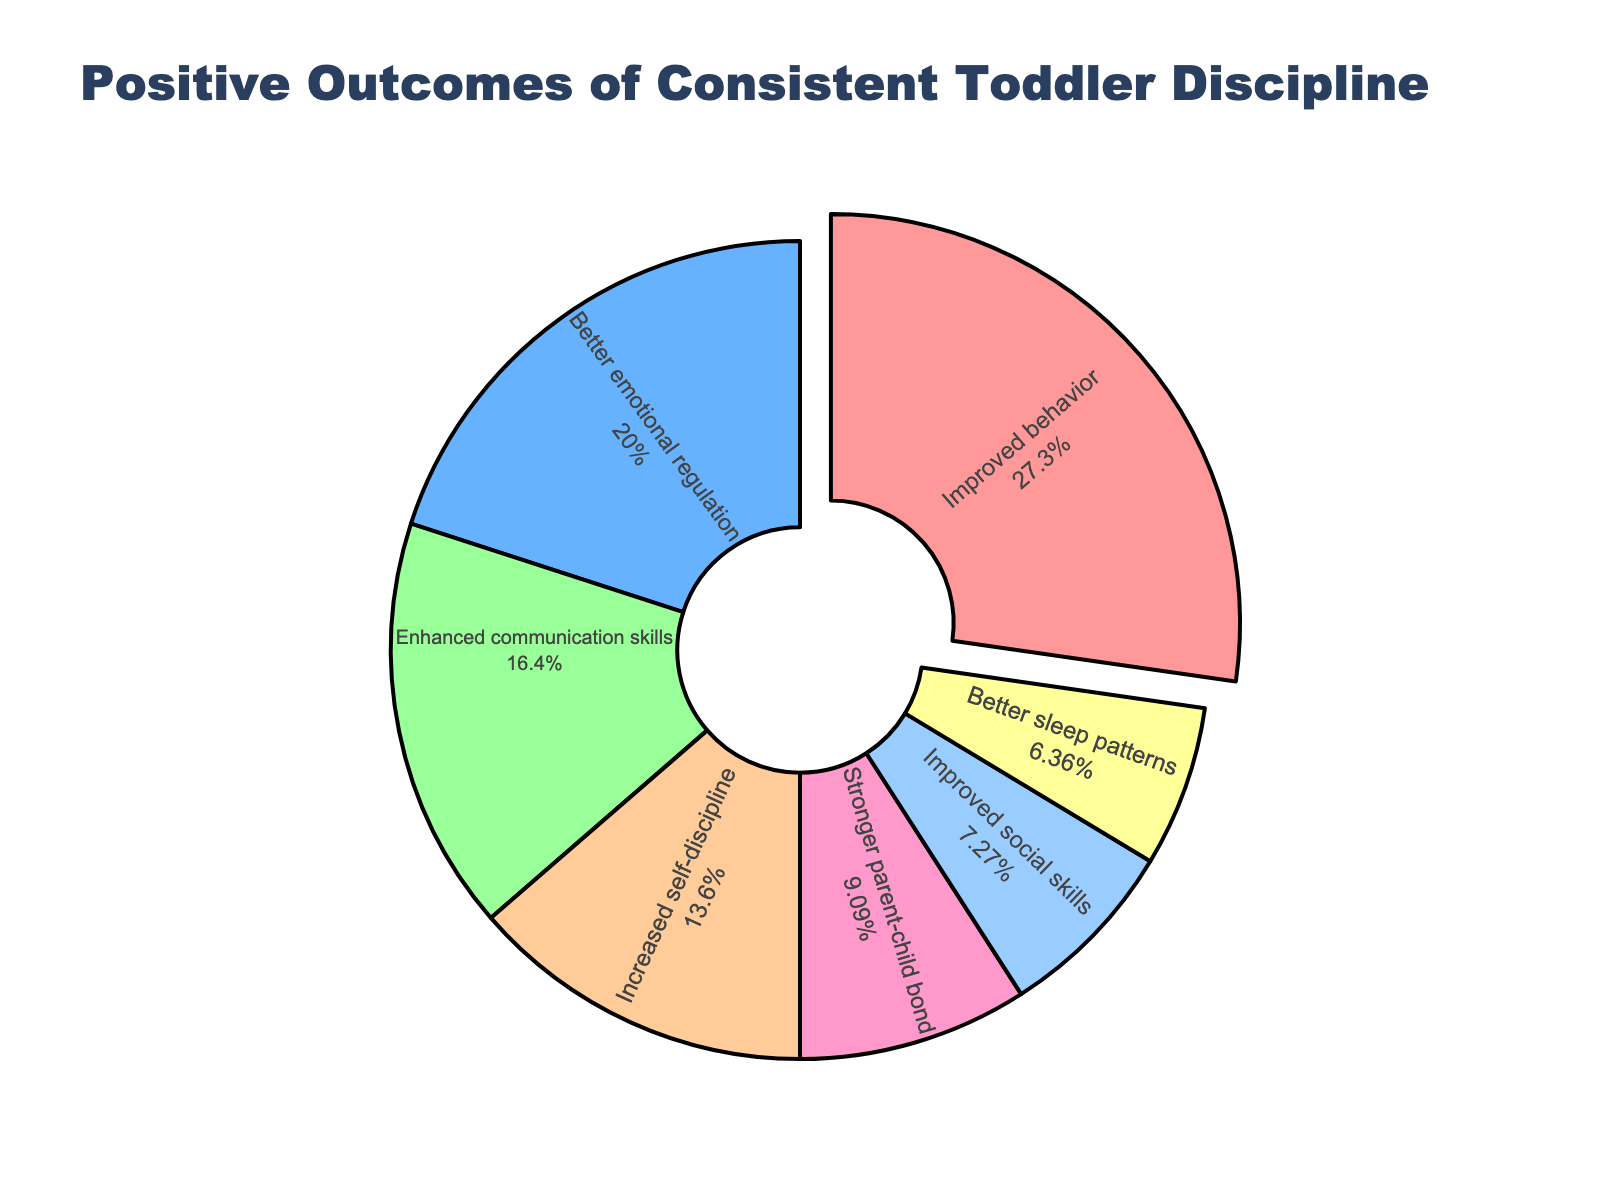What is the largest reported positive outcome of consistent toddler discipline? The largest positive outcome can be seen by identifying the segment that represents the greatest percentage of the pie chart. "Improved behavior" has the largest segment at 30%.
Answer: Improved behavior How much more frequently is "Improved behavior" reported compared to "Improved social skills"? The percentage for "Improved behavior" is 30%, and for "Improved social skills" it is 8%. The difference is calculated by subtracting the smaller percentage from the larger one (30% - 8%).
Answer: 22% Which positive outcome of consistent toddler discipline has the smallest reported percentage? By observing the pie chart, the smallest segment corresponds to "Better sleep patterns" with a percentage of 7%.
Answer: Better sleep patterns What is the total percentage of outcomes related to emotional and social skills? The percentages for "Better emotional regulation" and "Improved social skills" are 22% and 8%, respectively. Their total is the sum of these two percentages (22% + 8%).
Answer: 30% How does the percentage of "Enhanced communication skills" compare to "Increased self-discipline"? "Enhanced communication skills" accounts for 18% while "Increased self-discipline" accounts for 15%. Since 18% is greater than 15%, "Enhanced communication skills" is more frequently reported.
Answer: Enhanced communication skills is more frequently reported What is the combined percentage for "Better emotional regulation", "Enhanced communication skills", and "Increased self-discipline"? The combined percentage can be calculated by adding the percentages of these categories: 22% (Better emotional regulation) + 18% (Enhanced communication skills) + 15% (Increased self-discipline). The sum is 55%.
Answer: 55% What percentage is associated with the bond between parent and child? By looking at the pie chart, the percentage for the "Stronger parent-child bond" is shown to be 10%.
Answer: 10% Which categories are reported more frequently than "Stronger parent-child bond"? The percentages for the "Stronger parent-child bond" are compared against other categories. The categories reported more frequently are "Improved behavior" (30%), "Better emotional regulation" (22%), "Enhanced communication skills" (18%), and "Increased self-discipline" (15%).
Answer: Improved behavior, Better emotional regulation, Enhanced communication skills, Increased self-discipline What is the average percentage for "Improved behavior," "Better sleep patterns," and "Stronger parent-child bond"? The percentages for these categories are 30%, 7%, and 10%, respectively. To find the average, sum the percentages and then divide by the number of categories (30 + 7 + 10) / 3. This results in 15.67%.
Answer: 15.67% In terms of visual representation, which color is used for the "Improved behavior" segment? The "Improved behavior" segment is represented with the color closest to "#FF9999", which is a light red. Therefore, "Improved behavior" is shown in red.
Answer: Red 